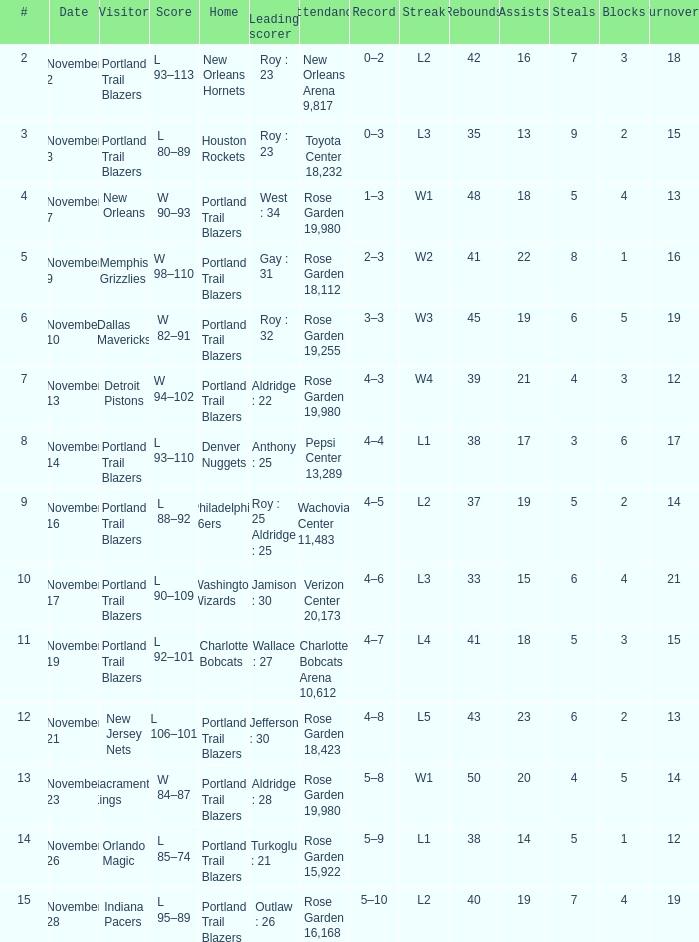 who is the leading scorer where home is charlotte bobcats Wallace : 27. 